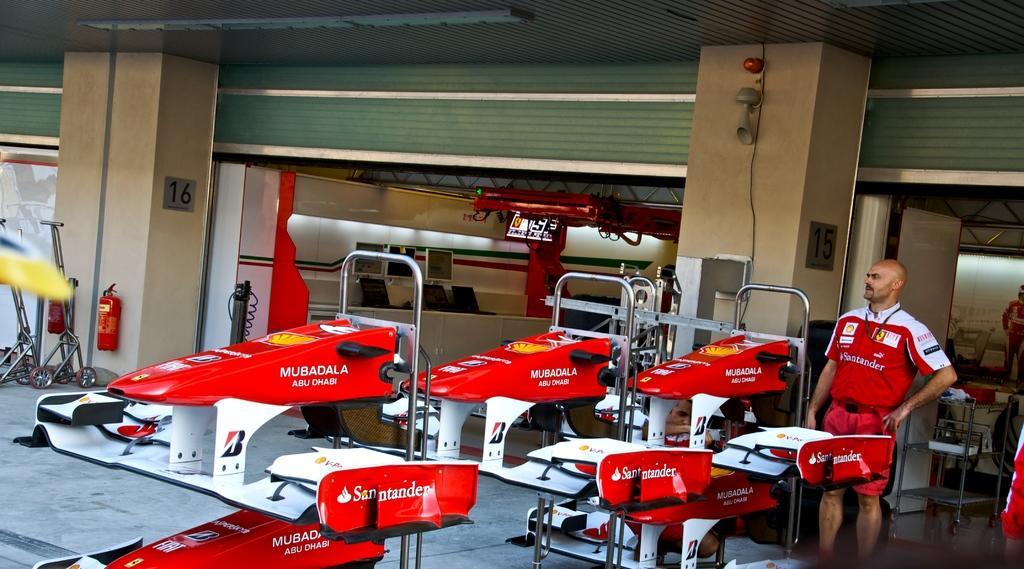How would you summarize this image in a sentence or two? In this picture, we see a man in the red T-shirt is standing. Beside him, we see the car racing frames. Behind him, we see a rack in which some objects are placed. Beside him, we see a pillar. On the left side, we see the cycles, fire extinguishers and a pillar. In the background, we see a wall on which clocks are placed. At the top, we see the roof of the building. 